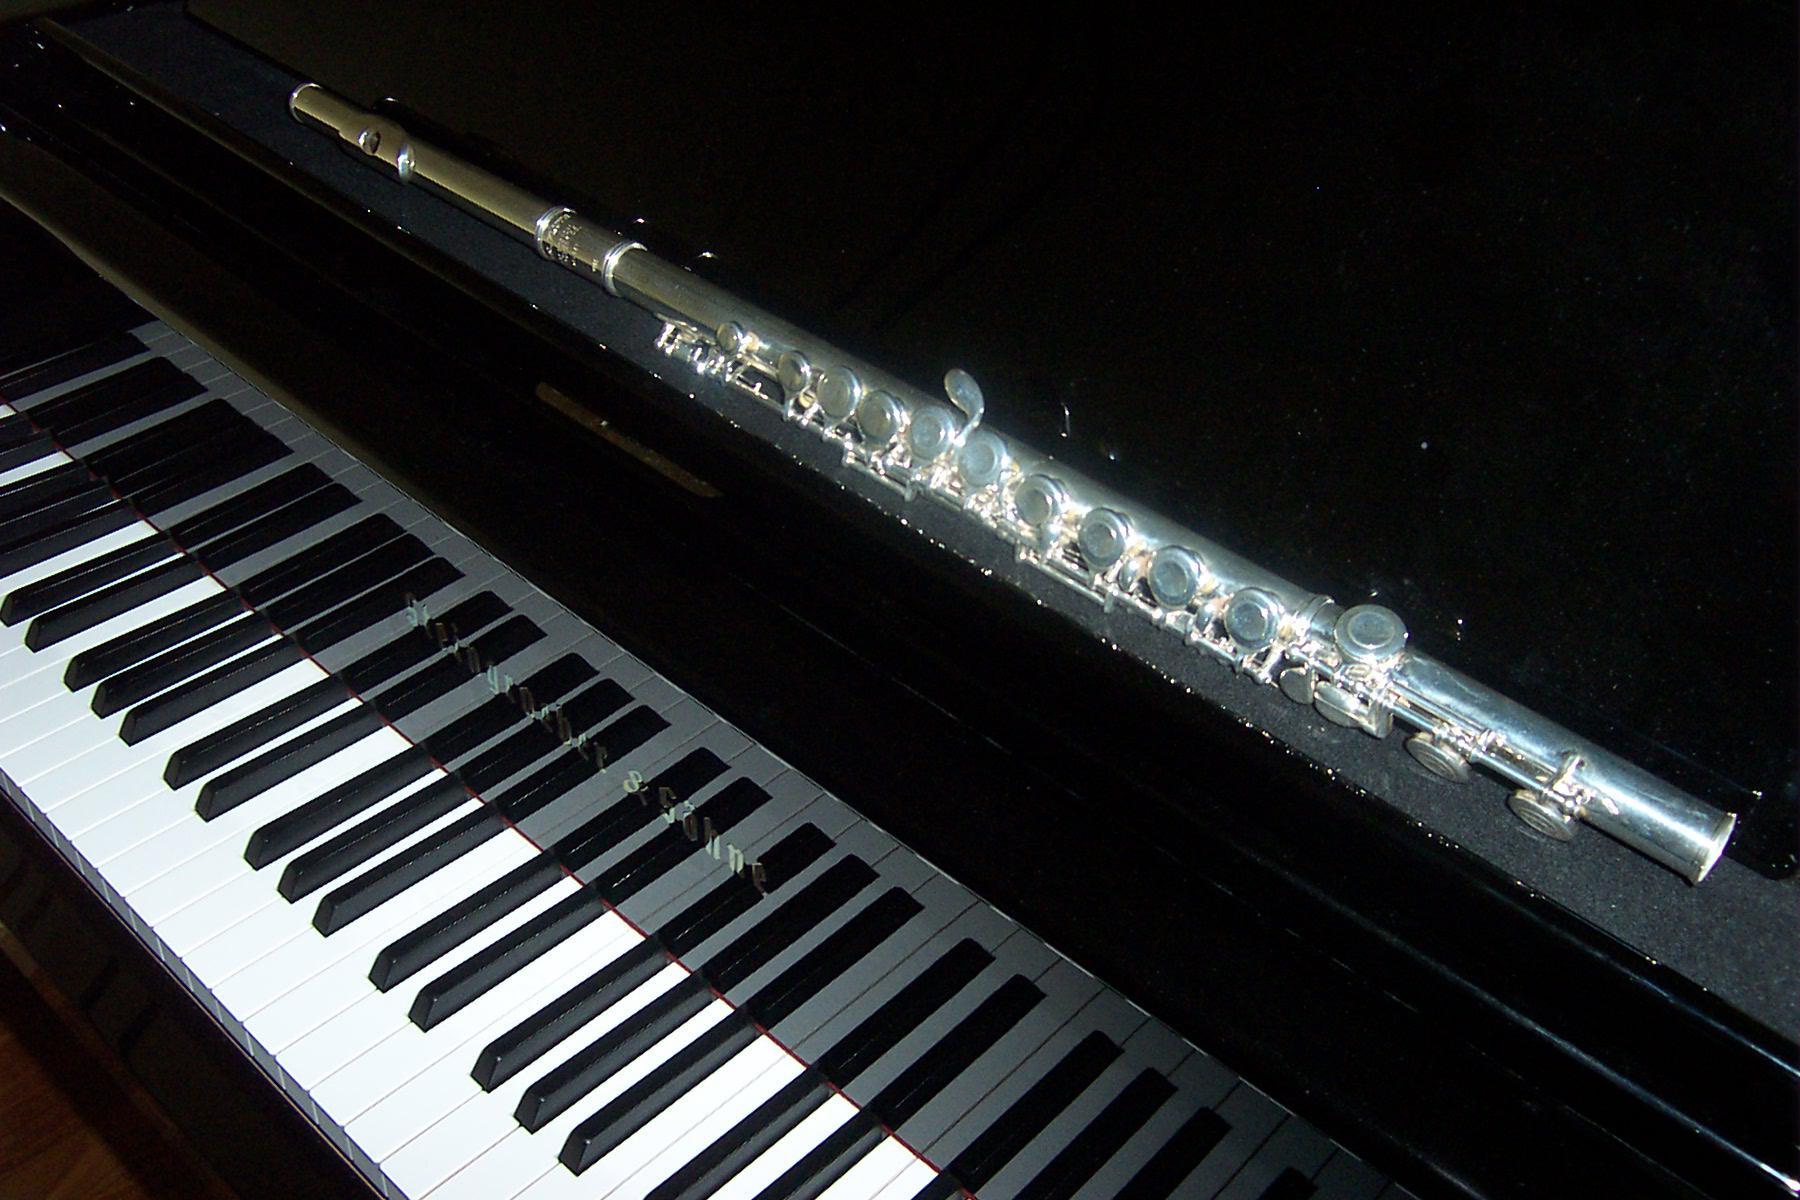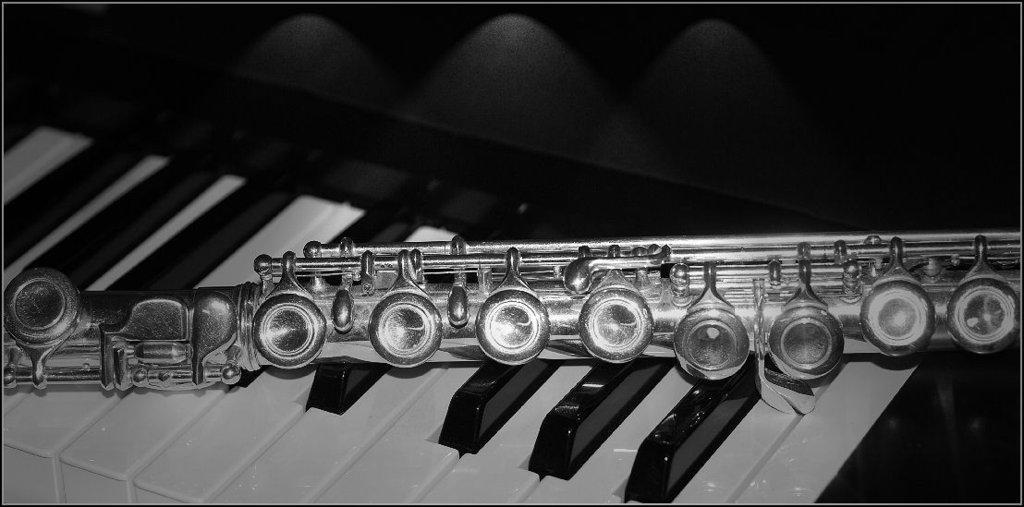The first image is the image on the left, the second image is the image on the right. Evaluate the accuracy of this statement regarding the images: "An image shows one silver wind instrument laid at an angle across the keys of a brown wood-grain piano that faces rightward.". Is it true? Answer yes or no. No. The first image is the image on the left, the second image is the image on the right. Assess this claim about the two images: "There is exactly one flute resting on piano keys.". Correct or not? Answer yes or no. Yes. 